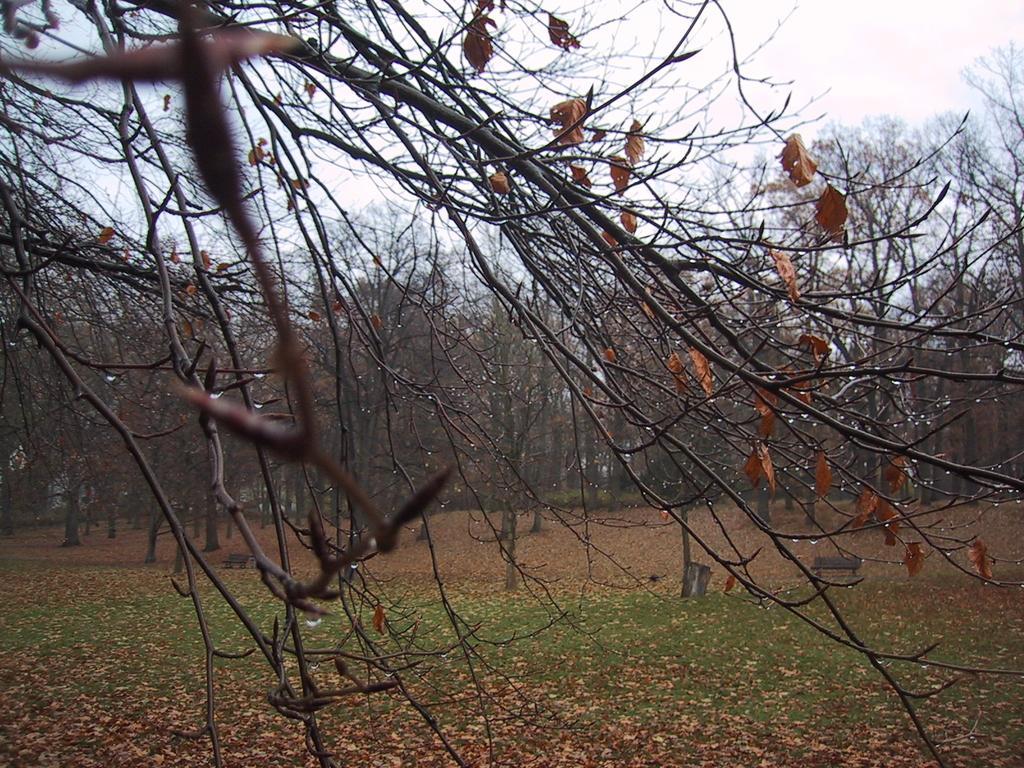Could you give a brief overview of what you see in this image? In this image in the foreground there are some trees, and in the background also there are trees. At the bottom there is grass and some dry leaves and sand, at the top of the image there is sky. 